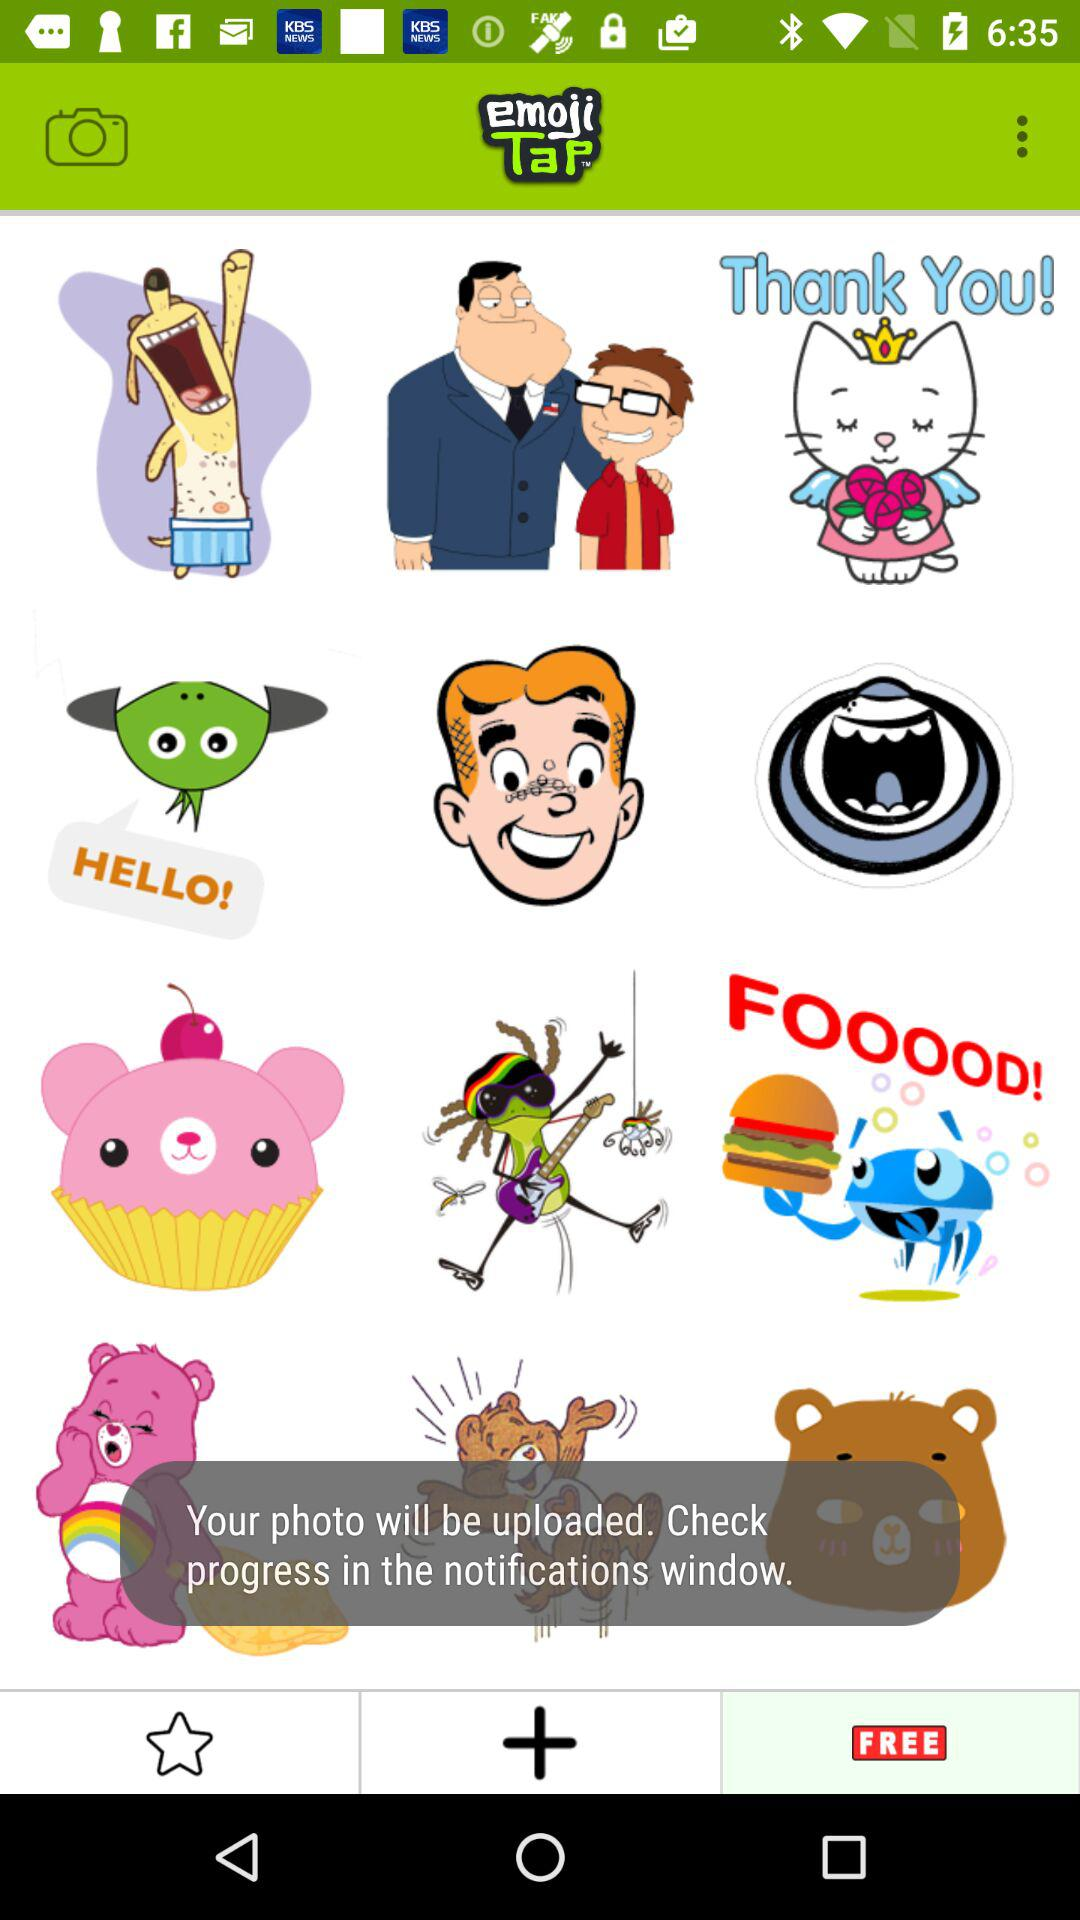Are these emojis added?
When the provided information is insufficient, respond with <no answer>. <no answer> 